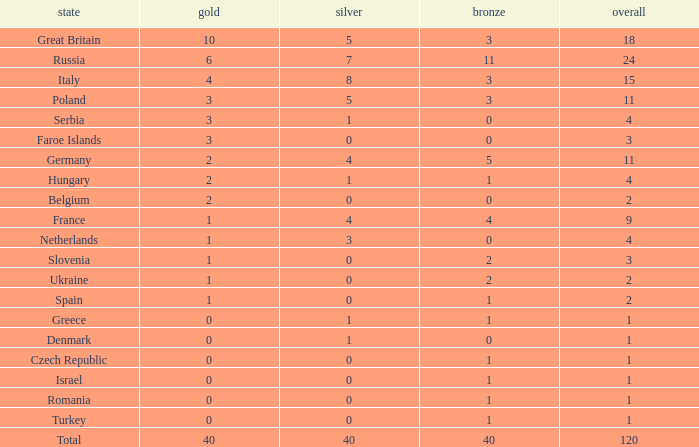What is the typical gold entry for the netherlands with a bronze entry exceeding 0? None. 